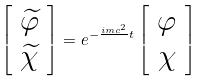Convert formula to latex. <formula><loc_0><loc_0><loc_500><loc_500>\left [ \begin{array} { c } { \widetilde { \varphi } } \\ { \widetilde { \chi } } \end{array} \right ] = e ^ { - \frac { i m c ^ { 2 } } { } t } \left [ \begin{array} { c } \varphi \\ \chi \end{array} \right ]</formula> 